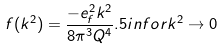<formula> <loc_0><loc_0><loc_500><loc_500>f ( k ^ { 2 } ) = \frac { - e _ { f } ^ { 2 } k ^ { 2 } } { 8 \pi ^ { 3 } Q ^ { 4 } } . 5 i n f o r k ^ { 2 } \rightarrow 0</formula> 